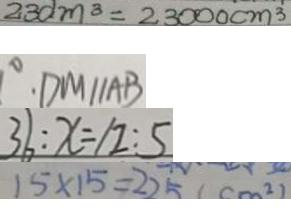Convert formula to latex. <formula><loc_0><loc_0><loc_500><loc_500>2 3 d m ^ { 3 } = 2 3 0 0 0 c m ^ { 3 } 
 \cdot D M / / A B 
 3 6 : x = 1 2 : 5 
 1 5 \times 1 5 = 2 2 5 ( c m ^ { 2 } )</formula> 